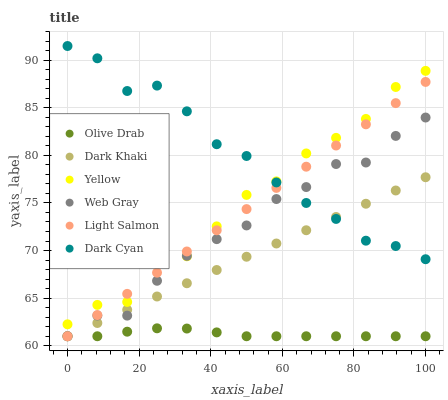Does Olive Drab have the minimum area under the curve?
Answer yes or no. Yes. Does Dark Cyan have the maximum area under the curve?
Answer yes or no. Yes. Does Web Gray have the minimum area under the curve?
Answer yes or no. No. Does Web Gray have the maximum area under the curve?
Answer yes or no. No. Is Light Salmon the smoothest?
Answer yes or no. Yes. Is Yellow the roughest?
Answer yes or no. Yes. Is Web Gray the smoothest?
Answer yes or no. No. Is Web Gray the roughest?
Answer yes or no. No. Does Light Salmon have the lowest value?
Answer yes or no. Yes. Does Yellow have the lowest value?
Answer yes or no. No. Does Dark Cyan have the highest value?
Answer yes or no. Yes. Does Web Gray have the highest value?
Answer yes or no. No. Is Dark Khaki less than Yellow?
Answer yes or no. Yes. Is Yellow greater than Olive Drab?
Answer yes or no. Yes. Does Yellow intersect Light Salmon?
Answer yes or no. Yes. Is Yellow less than Light Salmon?
Answer yes or no. No. Is Yellow greater than Light Salmon?
Answer yes or no. No. Does Dark Khaki intersect Yellow?
Answer yes or no. No. 